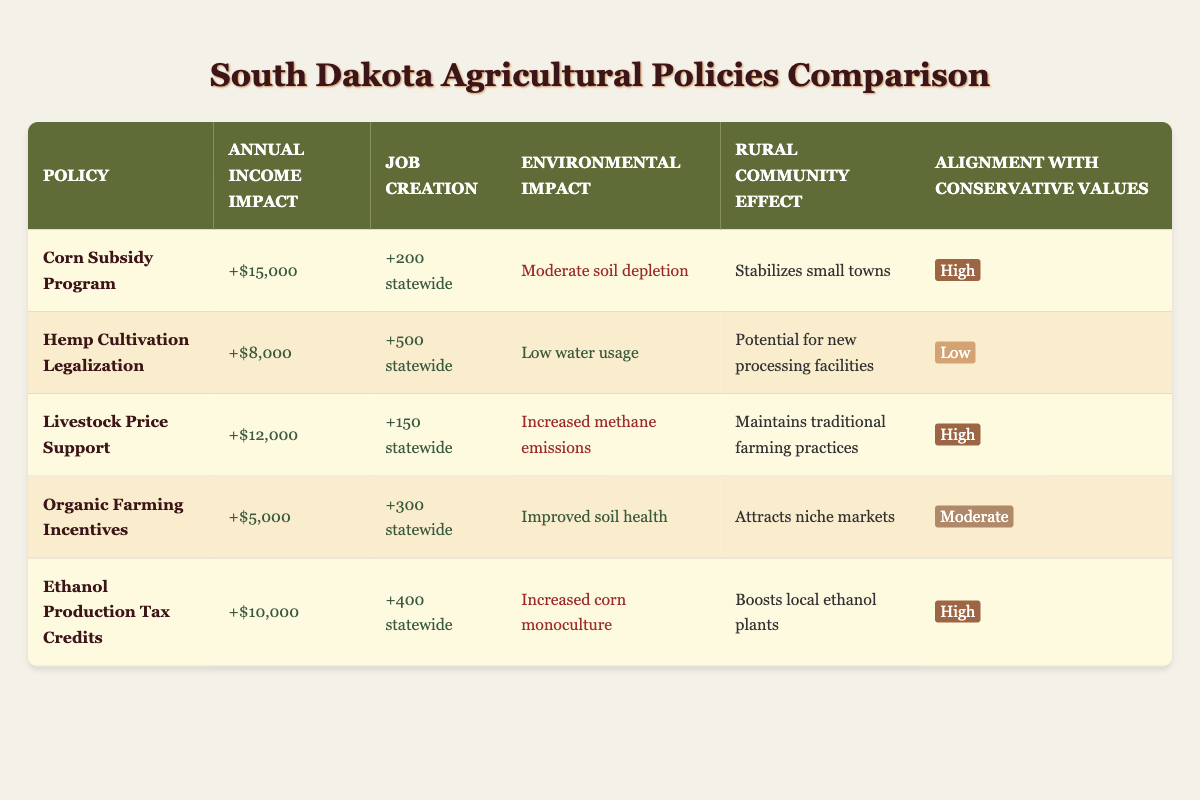What is the annual income impact of the Corn Subsidy Program? The table indicates the annual income impact of the Corn Subsidy Program is "+$15,000". Directly refer to the row corresponding to this policy.
Answer: +$15,000 Which policy has the highest job creation? To find the policy with the highest job creation, compare the job creation figures of all policies. The Hemp Cultivation Legalization shows "+500 statewide", which is the highest among the values listed in the table.
Answer: +500 statewide What is the environmental impact of Organic Farming Incentives? Look at the row for Organic Farming Incentives. The environmental impact listed is "Improved soil health". Therefore, that's the environmental impact of that policy.
Answer: Improved soil health How many total jobs will be created by both the Ethanol Production Tax Credits and the Livestock Price Support? To find the total job creation from these two policies, we add the individual job creation figures: Ethanol Production Tax Credits has "+400 statewide" and Livestock Price Support has "+150 statewide". So, 400 + 150 = 550 jobs created in total.
Answer: +550 statewide Is the Hemp Cultivation Legalization in line with conservative values? Referring to the table, Hemp Cultivation Legalization is marked with "Low" in the column for alignment with conservative values. Therefore, it is not aligned with conservative values.
Answer: No 